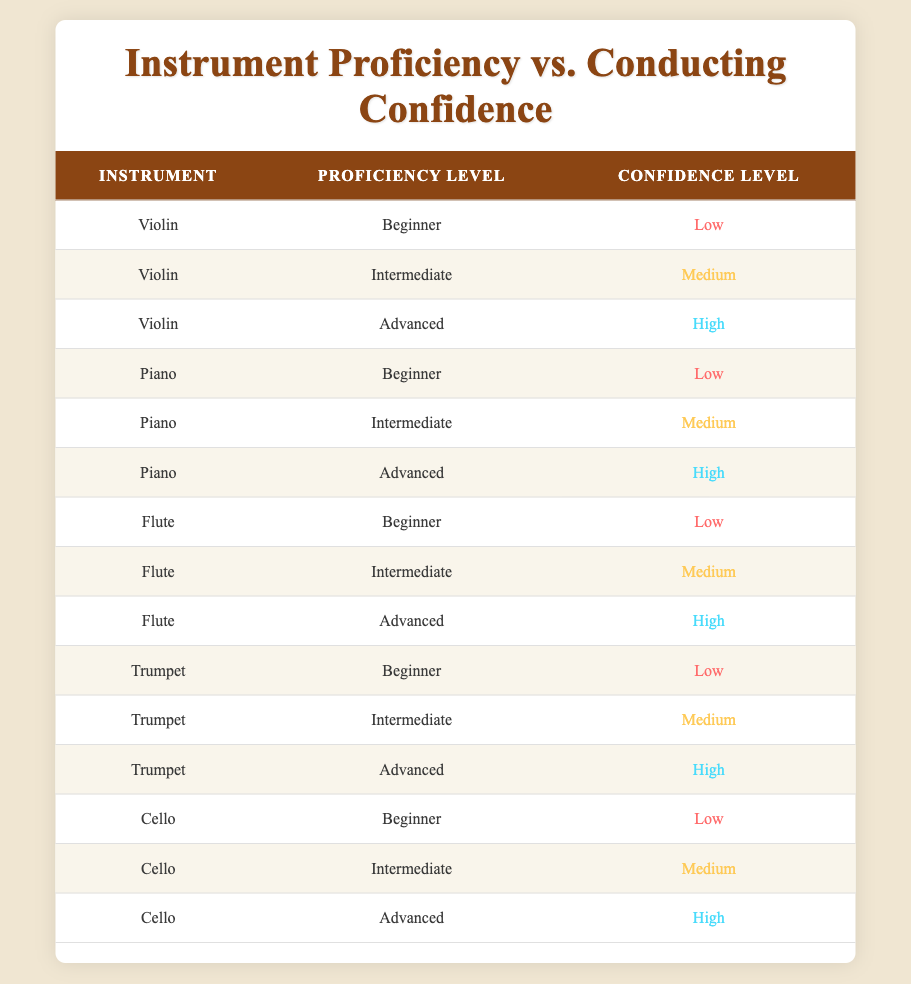What is the confidence level for the Advanced proficiency level on the Violin? According to the table, the Violin with an Advanced proficiency level displays a Confidence Level of "High."
Answer: High How many instruments have a Beginner proficiency level with a Low confidence level? The table lists five instruments (Violin, Piano, Flute, Trumpet, Cello) all marked as Beginner with a Low confidence level, so the count is 5.
Answer: 5 Is it true that all instruments listed have an Advanced proficiency level with a High confidence level? Yes, the table indicates that for all instruments (Violin, Piano, Flute, Trumpet, Cello), the Advanced proficiency level corresponds to a High confidence level.
Answer: Yes What is the average confidence level across all Intermediate proficiency levels? The Intermediate levels for all instruments show a Medium confidence level (3 instances). To find the average confidence level, since they are all the same, the average is Medium.
Answer: Medium Which instrument has the highest confidence level at the Beginner proficiency level? The table indicates that all Beginner proficiency levels for the instruments show a Low confidence level; therefore, no instrument has a higher Level than Low at this proficiency level.
Answer: No instrument has a higher confidence than Low What is the relationship between proficiency level and confidence level in general? Observing the table, as the proficiency level increases (from Beginner to Intermediate to Advanced), the confidence level also increases from Low to Medium and finally to High. This suggests a positive correlation.
Answer: Positive correlation How many instruments have an Intermediate proficiency level with a Medium confidence level? There are five instruments (Violin, Piano, Flute, Trumpet, Cello) that have an Intermediate proficiency level, all with a Medium confidence level, so the total count is 5.
Answer: 5 Is there any instrument that has a Medium confidence level at the Beginner proficiency level? Looking at the table, all instruments at the Beginner proficiency level show a Low confidence level, confirming that no instrument shows a Medium confidence level here.
Answer: No What are the confidence levels for the Trumpet at all proficiency levels? The Trumpet displays a Low confidence level at Beginner, Medium at Intermediate, and High at Advanced proficiency levels, corresponding to a consistent upward trend.
Answer: Low, Medium, High 